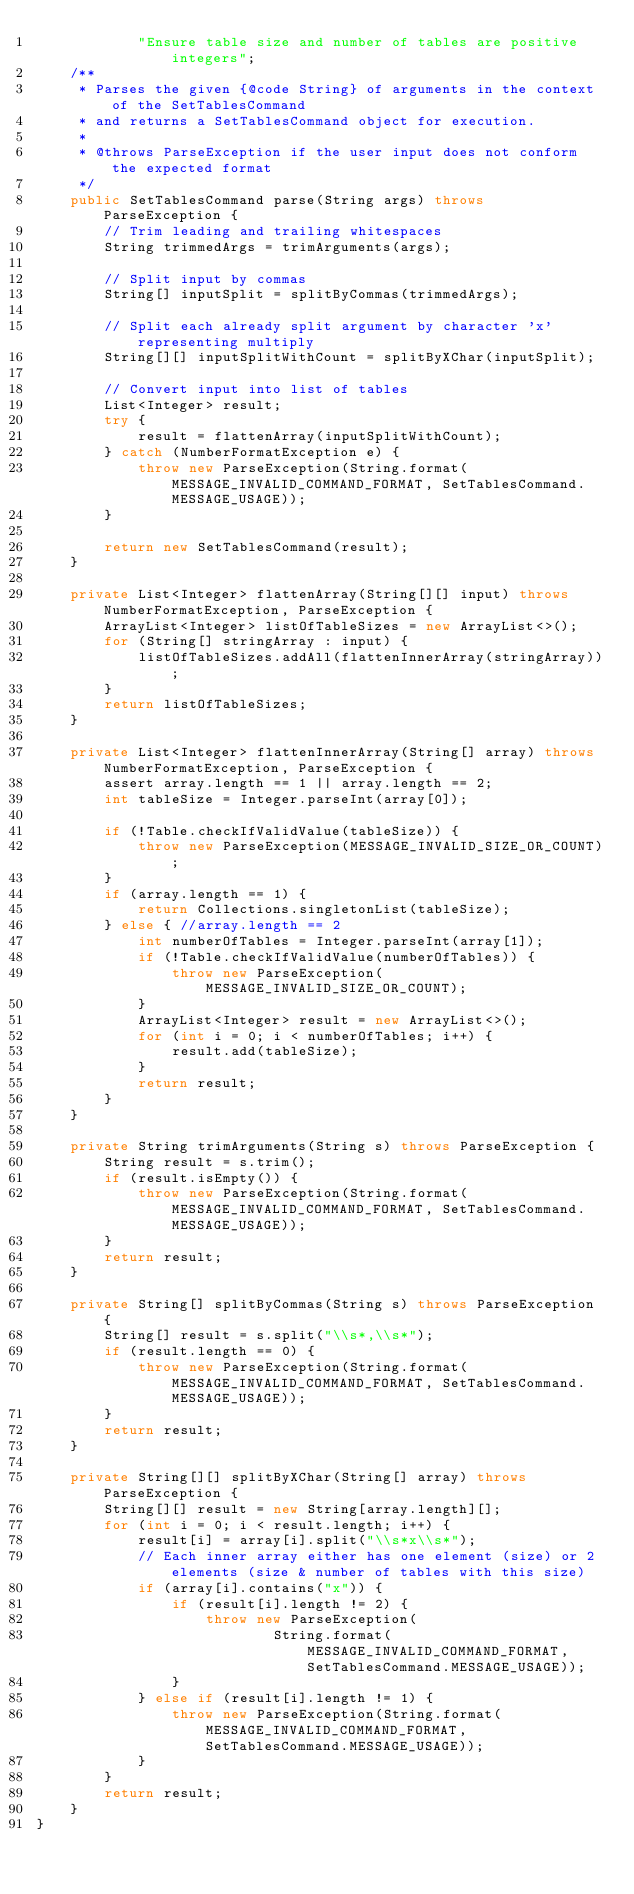Convert code to text. <code><loc_0><loc_0><loc_500><loc_500><_Java_>            "Ensure table size and number of tables are positive integers";
    /**
     * Parses the given {@code String} of arguments in the context of the SetTablesCommand
     * and returns a SetTablesCommand object for execution.
     *
     * @throws ParseException if the user input does not conform the expected format
     */
    public SetTablesCommand parse(String args) throws ParseException {
        // Trim leading and trailing whitespaces
        String trimmedArgs = trimArguments(args);

        // Split input by commas
        String[] inputSplit = splitByCommas(trimmedArgs);

        // Split each already split argument by character 'x' representing multiply
        String[][] inputSplitWithCount = splitByXChar(inputSplit);

        // Convert input into list of tables
        List<Integer> result;
        try {
            result = flattenArray(inputSplitWithCount);
        } catch (NumberFormatException e) {
            throw new ParseException(String.format(MESSAGE_INVALID_COMMAND_FORMAT, SetTablesCommand.MESSAGE_USAGE));
        }

        return new SetTablesCommand(result);
    }

    private List<Integer> flattenArray(String[][] input) throws NumberFormatException, ParseException {
        ArrayList<Integer> listOfTableSizes = new ArrayList<>();
        for (String[] stringArray : input) {
            listOfTableSizes.addAll(flattenInnerArray(stringArray));
        }
        return listOfTableSizes;
    }

    private List<Integer> flattenInnerArray(String[] array) throws NumberFormatException, ParseException {
        assert array.length == 1 || array.length == 2;
        int tableSize = Integer.parseInt(array[0]);

        if (!Table.checkIfValidValue(tableSize)) {
            throw new ParseException(MESSAGE_INVALID_SIZE_OR_COUNT);
        }
        if (array.length == 1) {
            return Collections.singletonList(tableSize);
        } else { //array.length == 2
            int numberOfTables = Integer.parseInt(array[1]);
            if (!Table.checkIfValidValue(numberOfTables)) {
                throw new ParseException(MESSAGE_INVALID_SIZE_OR_COUNT);
            }
            ArrayList<Integer> result = new ArrayList<>();
            for (int i = 0; i < numberOfTables; i++) {
                result.add(tableSize);
            }
            return result;
        }
    }

    private String trimArguments(String s) throws ParseException {
        String result = s.trim();
        if (result.isEmpty()) {
            throw new ParseException(String.format(MESSAGE_INVALID_COMMAND_FORMAT, SetTablesCommand.MESSAGE_USAGE));
        }
        return result;
    }

    private String[] splitByCommas(String s) throws ParseException {
        String[] result = s.split("\\s*,\\s*");
        if (result.length == 0) {
            throw new ParseException(String.format(MESSAGE_INVALID_COMMAND_FORMAT, SetTablesCommand.MESSAGE_USAGE));
        }
        return result;
    }

    private String[][] splitByXChar(String[] array) throws ParseException {
        String[][] result = new String[array.length][];
        for (int i = 0; i < result.length; i++) {
            result[i] = array[i].split("\\s*x\\s*");
            // Each inner array either has one element (size) or 2 elements (size & number of tables with this size)
            if (array[i].contains("x")) {
                if (result[i].length != 2) {
                    throw new ParseException(
                            String.format(MESSAGE_INVALID_COMMAND_FORMAT, SetTablesCommand.MESSAGE_USAGE));
                }
            } else if (result[i].length != 1) {
                throw new ParseException(String.format(MESSAGE_INVALID_COMMAND_FORMAT, SetTablesCommand.MESSAGE_USAGE));
            }
        }
        return result;
    }
}
</code> 